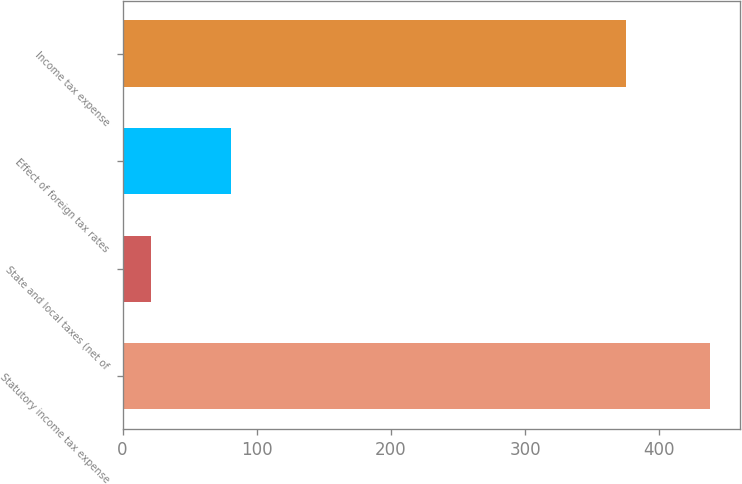Convert chart. <chart><loc_0><loc_0><loc_500><loc_500><bar_chart><fcel>Statutory income tax expense<fcel>State and local taxes (net of<fcel>Effect of foreign tax rates<fcel>Income tax expense<nl><fcel>438<fcel>21<fcel>81<fcel>375<nl></chart> 